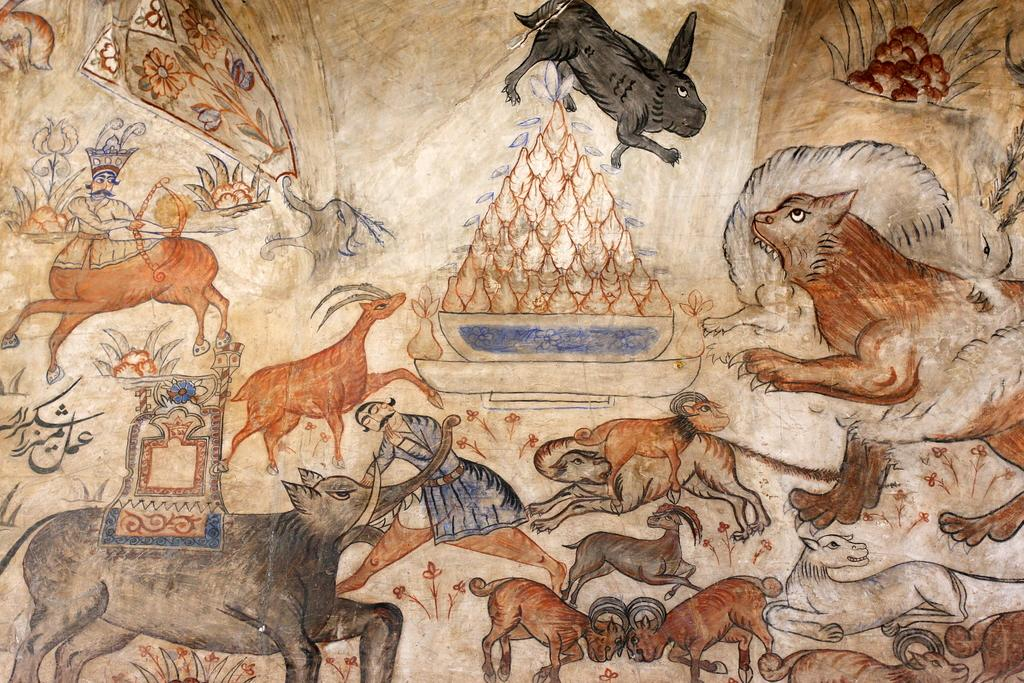What is present in the image that features drawings? There is a poster in the image that contains drawings. What types of drawings can be seen on the poster? The poster contains drawings of animals and a drawing of a man. What type of bridge is depicted in the image? There is no bridge present in the image; it features a poster with drawings of animals and a man. 